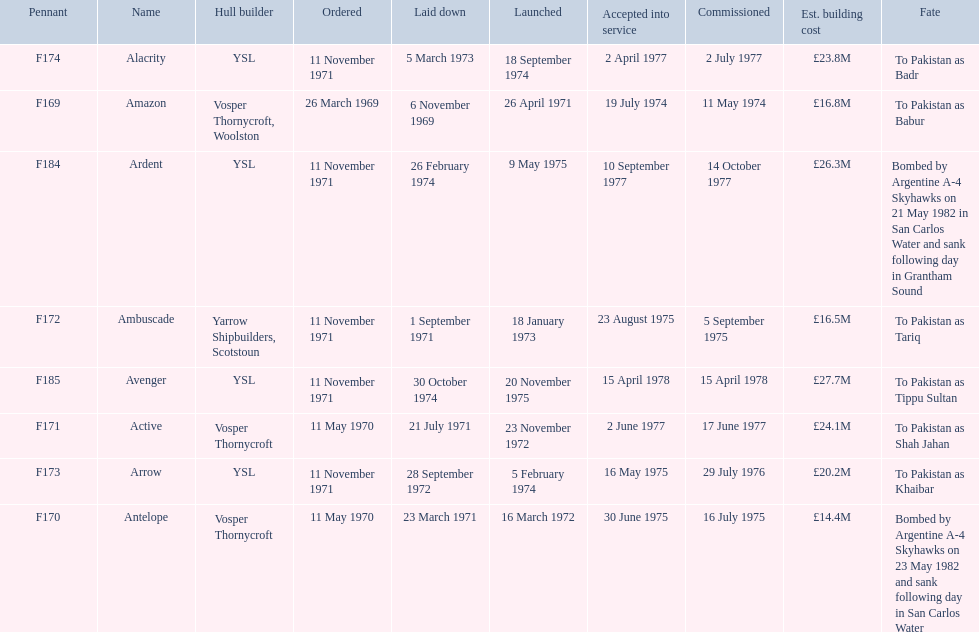How many ships were laid down in september? 2. 